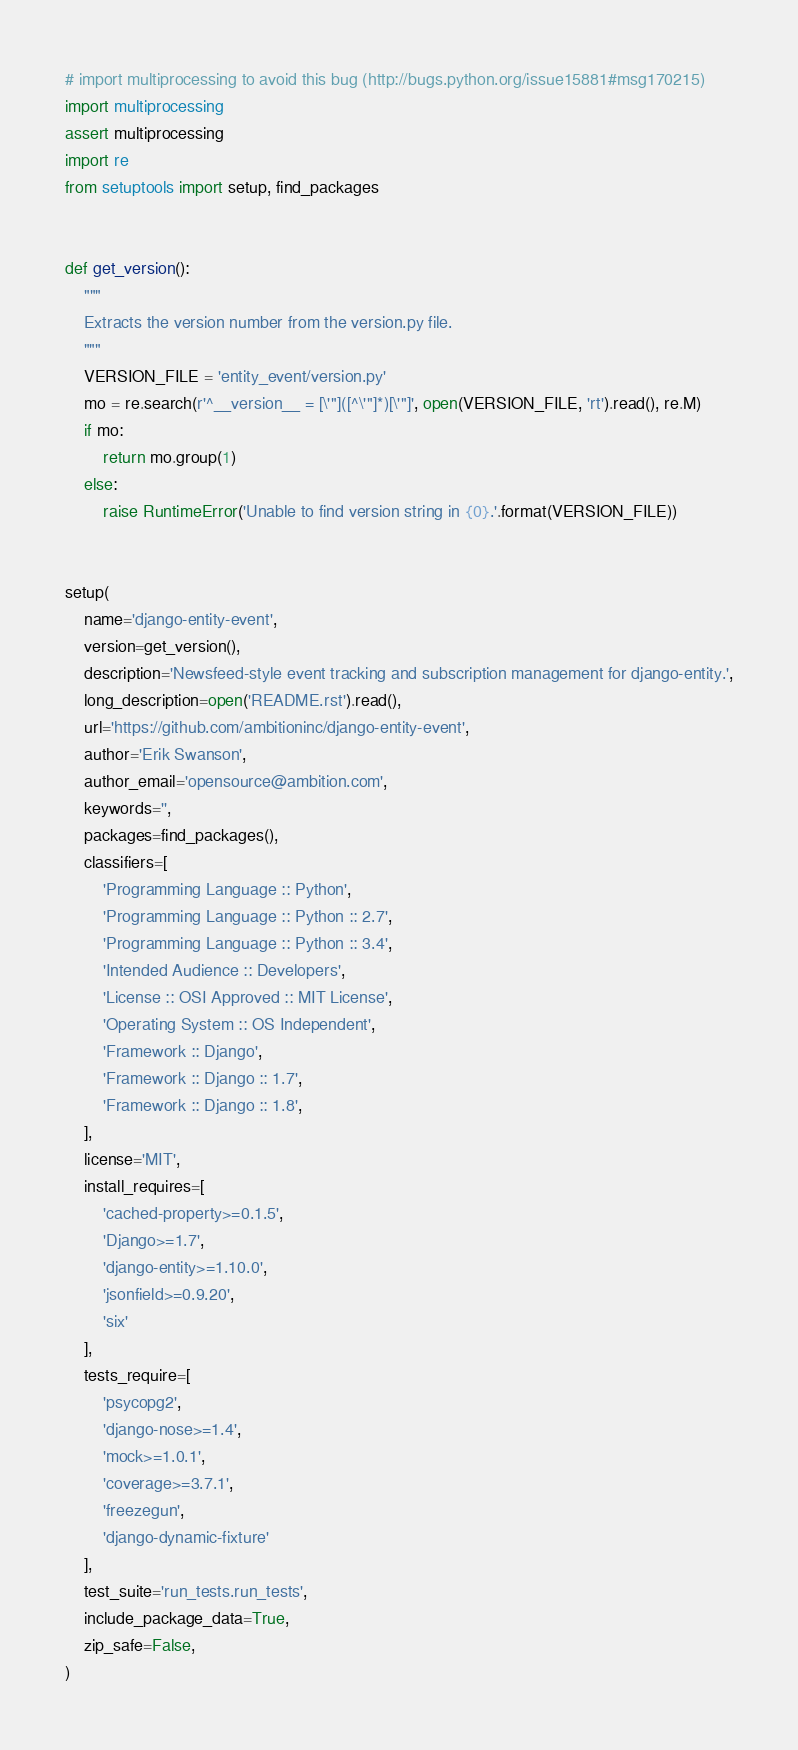<code> <loc_0><loc_0><loc_500><loc_500><_Python_># import multiprocessing to avoid this bug (http://bugs.python.org/issue15881#msg170215)
import multiprocessing
assert multiprocessing
import re
from setuptools import setup, find_packages


def get_version():
    """
    Extracts the version number from the version.py file.
    """
    VERSION_FILE = 'entity_event/version.py'
    mo = re.search(r'^__version__ = [\'"]([^\'"]*)[\'"]', open(VERSION_FILE, 'rt').read(), re.M)
    if mo:
        return mo.group(1)
    else:
        raise RuntimeError('Unable to find version string in {0}.'.format(VERSION_FILE))


setup(
    name='django-entity-event',
    version=get_version(),
    description='Newsfeed-style event tracking and subscription management for django-entity.',
    long_description=open('README.rst').read(),
    url='https://github.com/ambitioninc/django-entity-event',
    author='Erik Swanson',
    author_email='opensource@ambition.com',
    keywords='',
    packages=find_packages(),
    classifiers=[
        'Programming Language :: Python',
        'Programming Language :: Python :: 2.7',
        'Programming Language :: Python :: 3.4',
        'Intended Audience :: Developers',
        'License :: OSI Approved :: MIT License',
        'Operating System :: OS Independent',
        'Framework :: Django',
        'Framework :: Django :: 1.7',
        'Framework :: Django :: 1.8',
    ],
    license='MIT',
    install_requires=[
        'cached-property>=0.1.5',
        'Django>=1.7',
        'django-entity>=1.10.0',
        'jsonfield>=0.9.20',
        'six'
    ],
    tests_require=[
        'psycopg2',
        'django-nose>=1.4',
        'mock>=1.0.1',
        'coverage>=3.7.1',
        'freezegun',
        'django-dynamic-fixture'
    ],
    test_suite='run_tests.run_tests',
    include_package_data=True,
    zip_safe=False,
)
</code> 